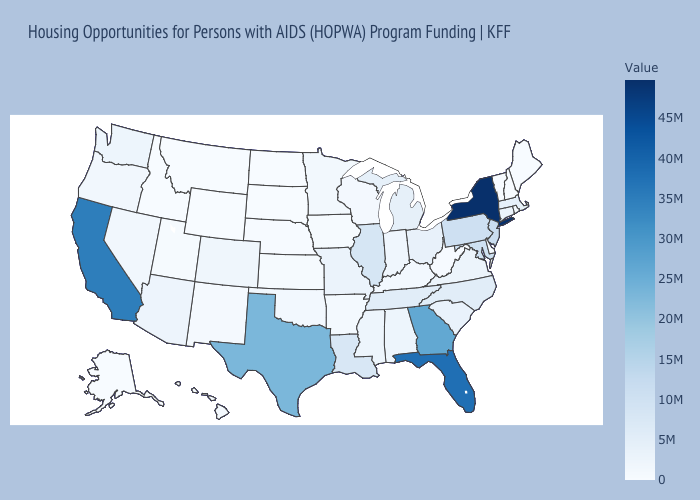Among the states that border Wyoming , does Colorado have the highest value?
Give a very brief answer. Yes. Which states have the lowest value in the Northeast?
Concise answer only. Maine, New Hampshire, Vermont. Among the states that border New Jersey , which have the highest value?
Short answer required. New York. Among the states that border Iowa , which have the lowest value?
Answer briefly. South Dakota. Among the states that border Indiana , does Michigan have the highest value?
Quick response, please. No. 